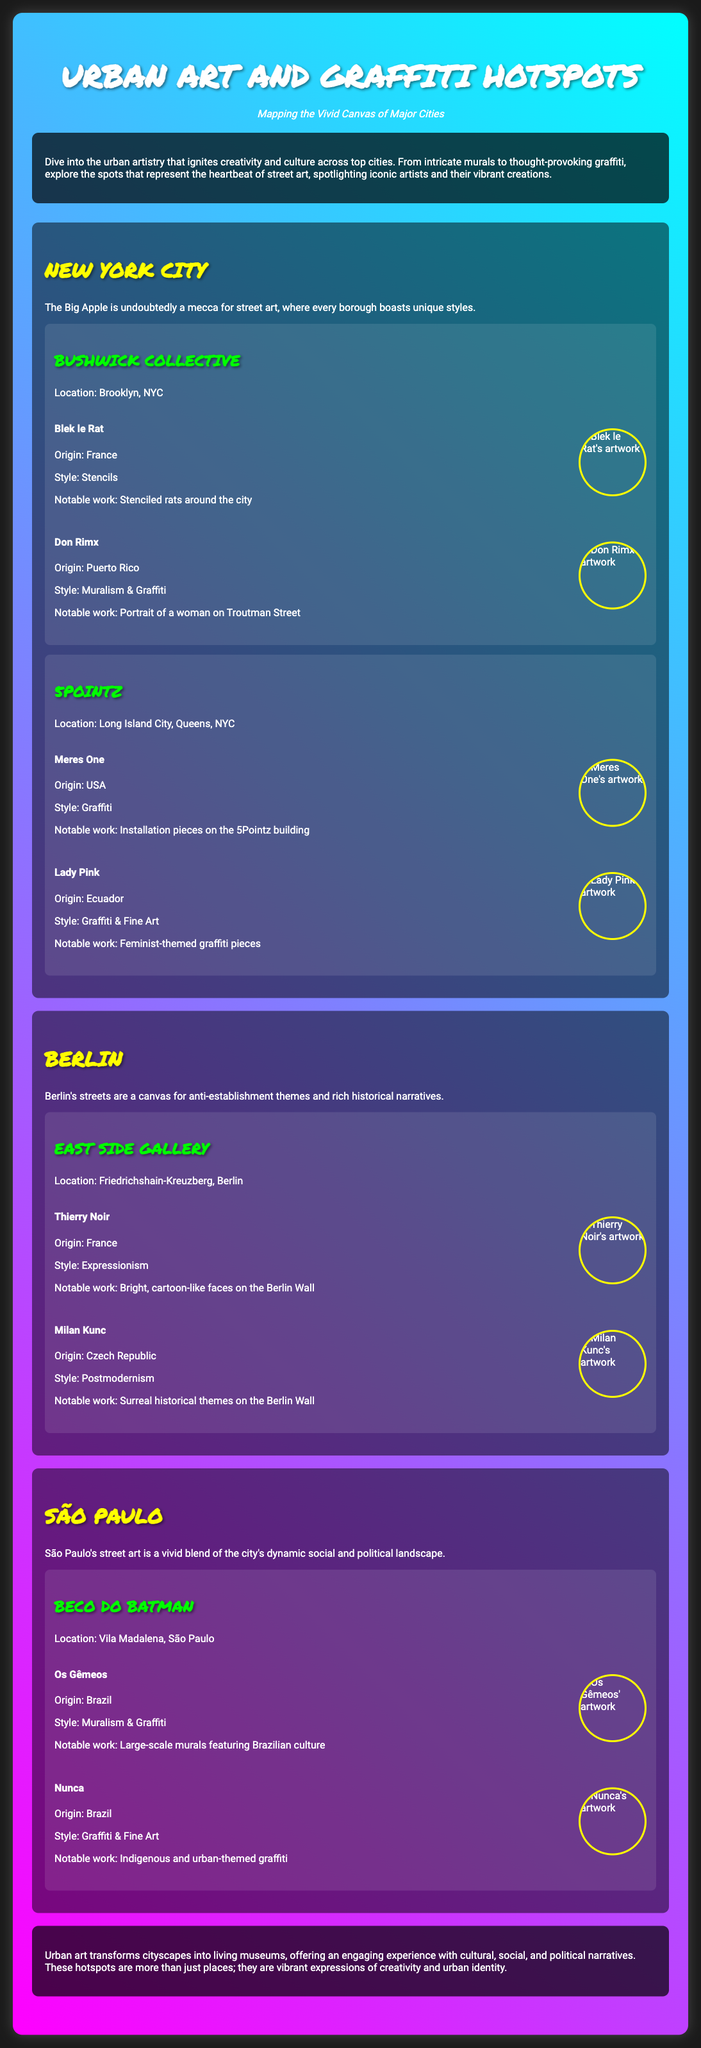What is the title of the poster? The title of the poster can be found at the top of the document, clearly stating the main theme of the poster.
Answer: Urban Art and Graffiti Hotspots Which city is known as a mecca for street art? The document refers to one city as a mecca for street art, indicating its prominence in this area.
Answer: New York City Who is the artist with a notable work of stenciled rats? This artist is mentioned within the New York City section and is recognized for their unique style.
Answer: Blek le Rat How many notable artists are listed for Beco do Batman? The document provides specific names of artists linked to this hotspot, indicating the number associated with it.
Answer: Two What style is Thierry Noir known for? The document specifies the artistic style of Thierry Noir, detailing his contribution to the urban art scene.
Answer: Expressionism Which location features murals by Os Gêmeos? This location is highlighted in the São Paulo section of the document as a significant hotspot for street art.
Answer: Beco do Batman What color is the text-shadow in the title? The design specifics of the title can be noted in the styling section of the document, referring to its visual characteristics.
Answer: rgba(0,0,0,0.5) What type of art does Lady Pink practice alongside graffiti? Lady Pink is noted for working in both graffiti and another artistic form, showcasing her versatility.
Answer: Fine Art 